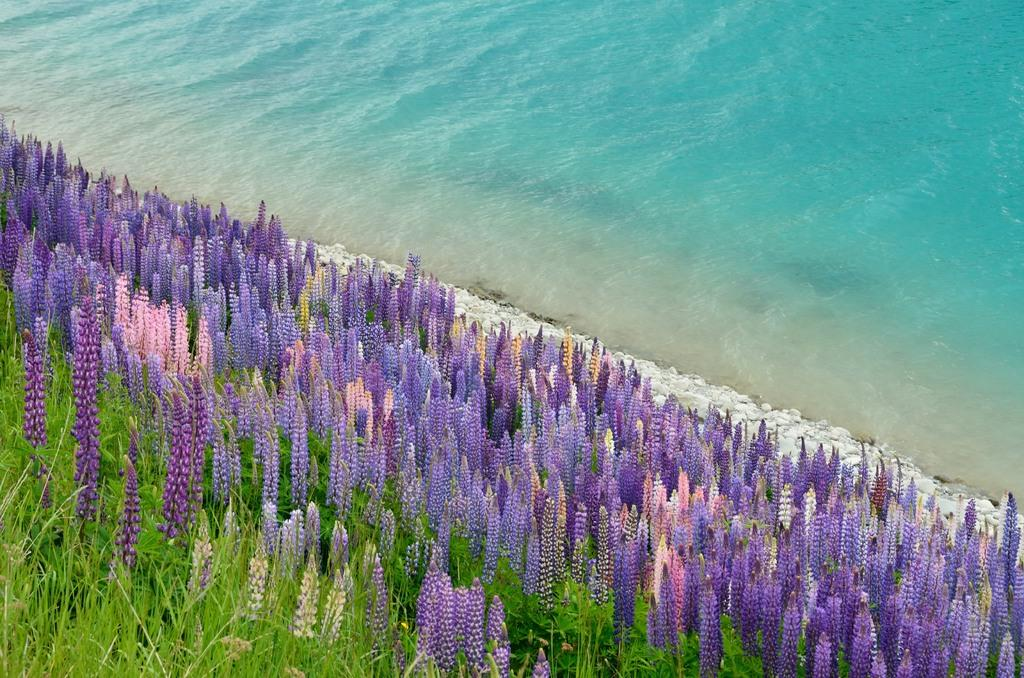What type of plants can be seen in the image? There are plants with flowers in the image. What distinguishing feature can be observed about the flowers? The flowers are in different colors. What can be seen on the ground in the background of the image? There are stones on the ground in the background. What natural element is visible in the background of the image? There is water visible in the background. How much money is being exchanged between the plants in the image? There is no money being exchanged in the image; it features plants with flowers and a background with stones and water. What type of brass object can be seen in the image? There is no brass object present in the image. 